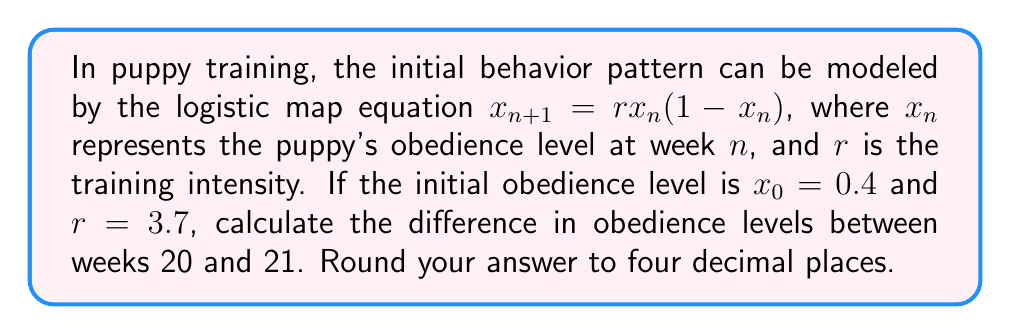Show me your answer to this math problem. To solve this problem, we need to iterate the logistic map equation for 21 weeks:

1) First, let's define our initial conditions:
   $x_0 = 0.4$
   $r = 3.7$

2) We'll use the logistic map equation: $x_{n+1} = rx_n(1-x_n)$

3) Let's calculate the first few iterations:
   $x_1 = 3.7 * 0.4 * (1-0.4) = 0.888$
   $x_2 = 3.7 * 0.888 * (1-0.888) = 0.3685$
   $x_3 = 3.7 * 0.3685 * (1-0.3685) = 0.8614$

4) We need to continue this process until we reach $x_{20}$ and $x_{21}$. Due to the chaotic nature of the logistic map at $r = 3.7$, we'll need to use a computer or calculator to perform these iterations accurately.

5) After 20 iterations, we get:
   $x_{20} \approx 0.3623$

6) For the 21st iteration:
   $x_{21} = 3.7 * 0.3623 * (1-0.3623) \approx 0.8544$

7) The difference between weeks 20 and 21 is:
   $|x_{21} - x_{20}| = |0.8544 - 0.3623| = 0.4921$

8) Rounding to four decimal places: 0.4921
Answer: 0.4921 